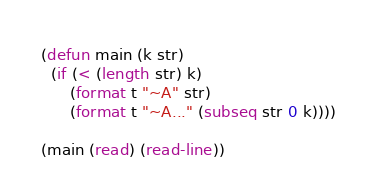<code> <loc_0><loc_0><loc_500><loc_500><_Lisp_>(defun main (k str)
  (if (< (length str) k)
      (format t "~A" str)
      (format t "~A..." (subseq str 0 k))))

(main (read) (read-line))
</code> 